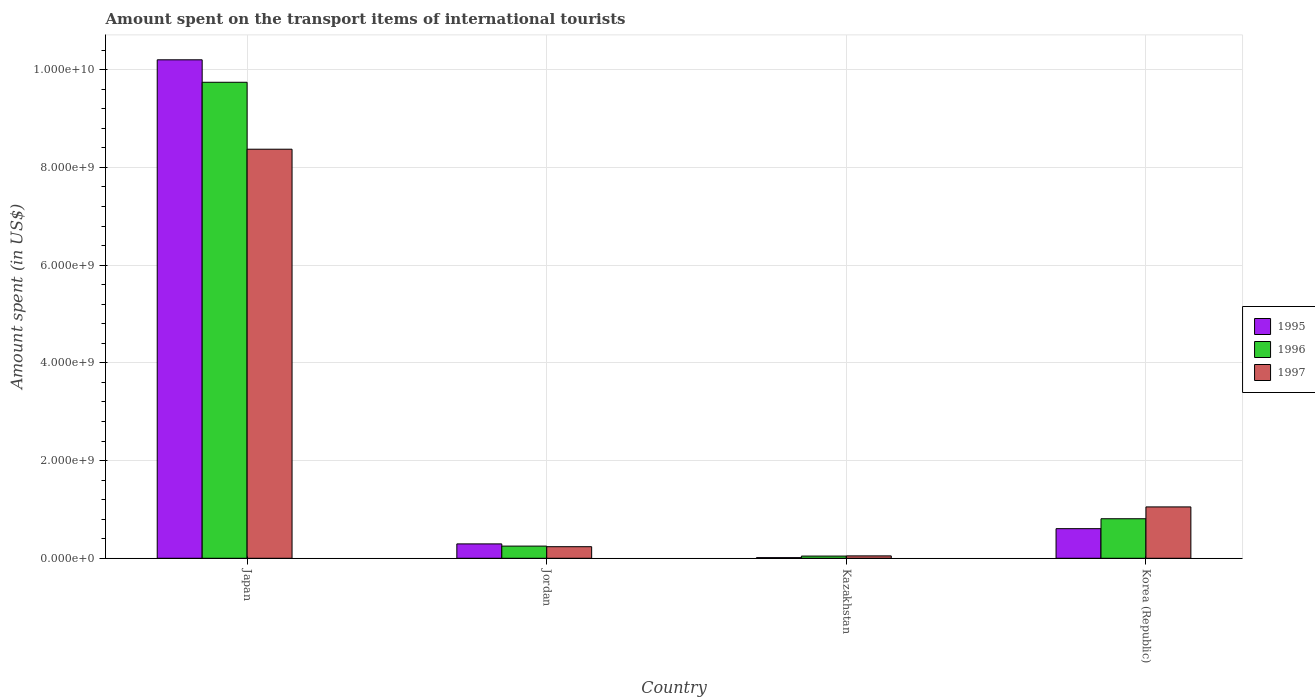How many different coloured bars are there?
Give a very brief answer. 3. Are the number of bars per tick equal to the number of legend labels?
Ensure brevity in your answer.  Yes. Are the number of bars on each tick of the X-axis equal?
Provide a succinct answer. Yes. How many bars are there on the 1st tick from the left?
Your response must be concise. 3. What is the label of the 3rd group of bars from the left?
Offer a very short reply. Kazakhstan. In how many cases, is the number of bars for a given country not equal to the number of legend labels?
Ensure brevity in your answer.  0. What is the amount spent on the transport items of international tourists in 1997 in Japan?
Provide a short and direct response. 8.37e+09. Across all countries, what is the maximum amount spent on the transport items of international tourists in 1996?
Provide a succinct answer. 9.74e+09. Across all countries, what is the minimum amount spent on the transport items of international tourists in 1996?
Keep it short and to the point. 4.50e+07. In which country was the amount spent on the transport items of international tourists in 1997 maximum?
Offer a terse response. Japan. In which country was the amount spent on the transport items of international tourists in 1997 minimum?
Offer a very short reply. Kazakhstan. What is the total amount spent on the transport items of international tourists in 1996 in the graph?
Provide a short and direct response. 1.08e+1. What is the difference between the amount spent on the transport items of international tourists in 1995 in Jordan and that in Kazakhstan?
Keep it short and to the point. 2.81e+08. What is the difference between the amount spent on the transport items of international tourists in 1997 in Jordan and the amount spent on the transport items of international tourists in 1995 in Kazakhstan?
Make the answer very short. 2.24e+08. What is the average amount spent on the transport items of international tourists in 1995 per country?
Keep it short and to the point. 2.78e+09. What is the difference between the amount spent on the transport items of international tourists of/in 1997 and amount spent on the transport items of international tourists of/in 1996 in Jordan?
Give a very brief answer. -1.20e+07. What is the ratio of the amount spent on the transport items of international tourists in 1996 in Japan to that in Jordan?
Ensure brevity in your answer.  39.12. Is the difference between the amount spent on the transport items of international tourists in 1997 in Jordan and Kazakhstan greater than the difference between the amount spent on the transport items of international tourists in 1996 in Jordan and Kazakhstan?
Your answer should be compact. No. What is the difference between the highest and the second highest amount spent on the transport items of international tourists in 1995?
Ensure brevity in your answer.  9.60e+09. What is the difference between the highest and the lowest amount spent on the transport items of international tourists in 1995?
Keep it short and to the point. 1.02e+1. Is the sum of the amount spent on the transport items of international tourists in 1996 in Jordan and Kazakhstan greater than the maximum amount spent on the transport items of international tourists in 1995 across all countries?
Keep it short and to the point. No. What does the 3rd bar from the right in Japan represents?
Your answer should be compact. 1995. What is the difference between two consecutive major ticks on the Y-axis?
Provide a short and direct response. 2.00e+09. Are the values on the major ticks of Y-axis written in scientific E-notation?
Your answer should be compact. Yes. Does the graph contain any zero values?
Provide a short and direct response. No. How many legend labels are there?
Offer a very short reply. 3. What is the title of the graph?
Offer a terse response. Amount spent on the transport items of international tourists. Does "2011" appear as one of the legend labels in the graph?
Your answer should be compact. No. What is the label or title of the Y-axis?
Your response must be concise. Amount spent (in US$). What is the Amount spent (in US$) in 1995 in Japan?
Make the answer very short. 1.02e+1. What is the Amount spent (in US$) in 1996 in Japan?
Your response must be concise. 9.74e+09. What is the Amount spent (in US$) of 1997 in Japan?
Provide a short and direct response. 8.37e+09. What is the Amount spent (in US$) of 1995 in Jordan?
Provide a succinct answer. 2.94e+08. What is the Amount spent (in US$) of 1996 in Jordan?
Your answer should be compact. 2.49e+08. What is the Amount spent (in US$) of 1997 in Jordan?
Provide a short and direct response. 2.37e+08. What is the Amount spent (in US$) in 1995 in Kazakhstan?
Your answer should be compact. 1.30e+07. What is the Amount spent (in US$) in 1996 in Kazakhstan?
Your response must be concise. 4.50e+07. What is the Amount spent (in US$) of 1997 in Kazakhstan?
Make the answer very short. 4.90e+07. What is the Amount spent (in US$) of 1995 in Korea (Republic)?
Your answer should be compact. 6.06e+08. What is the Amount spent (in US$) in 1996 in Korea (Republic)?
Your answer should be very brief. 8.09e+08. What is the Amount spent (in US$) of 1997 in Korea (Republic)?
Provide a short and direct response. 1.05e+09. Across all countries, what is the maximum Amount spent (in US$) in 1995?
Your answer should be very brief. 1.02e+1. Across all countries, what is the maximum Amount spent (in US$) in 1996?
Offer a terse response. 9.74e+09. Across all countries, what is the maximum Amount spent (in US$) in 1997?
Give a very brief answer. 8.37e+09. Across all countries, what is the minimum Amount spent (in US$) of 1995?
Keep it short and to the point. 1.30e+07. Across all countries, what is the minimum Amount spent (in US$) in 1996?
Ensure brevity in your answer.  4.50e+07. Across all countries, what is the minimum Amount spent (in US$) of 1997?
Your response must be concise. 4.90e+07. What is the total Amount spent (in US$) in 1995 in the graph?
Make the answer very short. 1.11e+1. What is the total Amount spent (in US$) in 1996 in the graph?
Offer a very short reply. 1.08e+1. What is the total Amount spent (in US$) of 1997 in the graph?
Your answer should be very brief. 9.71e+09. What is the difference between the Amount spent (in US$) of 1995 in Japan and that in Jordan?
Provide a succinct answer. 9.91e+09. What is the difference between the Amount spent (in US$) of 1996 in Japan and that in Jordan?
Keep it short and to the point. 9.49e+09. What is the difference between the Amount spent (in US$) of 1997 in Japan and that in Jordan?
Keep it short and to the point. 8.14e+09. What is the difference between the Amount spent (in US$) in 1995 in Japan and that in Kazakhstan?
Your answer should be very brief. 1.02e+1. What is the difference between the Amount spent (in US$) in 1996 in Japan and that in Kazakhstan?
Provide a succinct answer. 9.70e+09. What is the difference between the Amount spent (in US$) in 1997 in Japan and that in Kazakhstan?
Provide a short and direct response. 8.32e+09. What is the difference between the Amount spent (in US$) of 1995 in Japan and that in Korea (Republic)?
Keep it short and to the point. 9.60e+09. What is the difference between the Amount spent (in US$) in 1996 in Japan and that in Korea (Republic)?
Offer a terse response. 8.93e+09. What is the difference between the Amount spent (in US$) in 1997 in Japan and that in Korea (Republic)?
Your answer should be very brief. 7.32e+09. What is the difference between the Amount spent (in US$) of 1995 in Jordan and that in Kazakhstan?
Keep it short and to the point. 2.81e+08. What is the difference between the Amount spent (in US$) of 1996 in Jordan and that in Kazakhstan?
Make the answer very short. 2.04e+08. What is the difference between the Amount spent (in US$) of 1997 in Jordan and that in Kazakhstan?
Your answer should be very brief. 1.88e+08. What is the difference between the Amount spent (in US$) in 1995 in Jordan and that in Korea (Republic)?
Offer a very short reply. -3.12e+08. What is the difference between the Amount spent (in US$) in 1996 in Jordan and that in Korea (Republic)?
Offer a terse response. -5.60e+08. What is the difference between the Amount spent (in US$) of 1997 in Jordan and that in Korea (Republic)?
Your answer should be very brief. -8.14e+08. What is the difference between the Amount spent (in US$) in 1995 in Kazakhstan and that in Korea (Republic)?
Provide a short and direct response. -5.93e+08. What is the difference between the Amount spent (in US$) of 1996 in Kazakhstan and that in Korea (Republic)?
Your response must be concise. -7.64e+08. What is the difference between the Amount spent (in US$) of 1997 in Kazakhstan and that in Korea (Republic)?
Make the answer very short. -1.00e+09. What is the difference between the Amount spent (in US$) in 1995 in Japan and the Amount spent (in US$) in 1996 in Jordan?
Your answer should be very brief. 9.95e+09. What is the difference between the Amount spent (in US$) in 1995 in Japan and the Amount spent (in US$) in 1997 in Jordan?
Provide a short and direct response. 9.96e+09. What is the difference between the Amount spent (in US$) of 1996 in Japan and the Amount spent (in US$) of 1997 in Jordan?
Offer a very short reply. 9.50e+09. What is the difference between the Amount spent (in US$) in 1995 in Japan and the Amount spent (in US$) in 1996 in Kazakhstan?
Make the answer very short. 1.02e+1. What is the difference between the Amount spent (in US$) of 1995 in Japan and the Amount spent (in US$) of 1997 in Kazakhstan?
Provide a succinct answer. 1.02e+1. What is the difference between the Amount spent (in US$) of 1996 in Japan and the Amount spent (in US$) of 1997 in Kazakhstan?
Provide a succinct answer. 9.69e+09. What is the difference between the Amount spent (in US$) in 1995 in Japan and the Amount spent (in US$) in 1996 in Korea (Republic)?
Your response must be concise. 9.39e+09. What is the difference between the Amount spent (in US$) in 1995 in Japan and the Amount spent (in US$) in 1997 in Korea (Republic)?
Make the answer very short. 9.15e+09. What is the difference between the Amount spent (in US$) of 1996 in Japan and the Amount spent (in US$) of 1997 in Korea (Republic)?
Provide a short and direct response. 8.69e+09. What is the difference between the Amount spent (in US$) of 1995 in Jordan and the Amount spent (in US$) of 1996 in Kazakhstan?
Provide a short and direct response. 2.49e+08. What is the difference between the Amount spent (in US$) in 1995 in Jordan and the Amount spent (in US$) in 1997 in Kazakhstan?
Your response must be concise. 2.45e+08. What is the difference between the Amount spent (in US$) of 1996 in Jordan and the Amount spent (in US$) of 1997 in Kazakhstan?
Provide a succinct answer. 2.00e+08. What is the difference between the Amount spent (in US$) in 1995 in Jordan and the Amount spent (in US$) in 1996 in Korea (Republic)?
Provide a succinct answer. -5.15e+08. What is the difference between the Amount spent (in US$) of 1995 in Jordan and the Amount spent (in US$) of 1997 in Korea (Republic)?
Provide a short and direct response. -7.57e+08. What is the difference between the Amount spent (in US$) in 1996 in Jordan and the Amount spent (in US$) in 1997 in Korea (Republic)?
Your answer should be very brief. -8.02e+08. What is the difference between the Amount spent (in US$) in 1995 in Kazakhstan and the Amount spent (in US$) in 1996 in Korea (Republic)?
Provide a short and direct response. -7.96e+08. What is the difference between the Amount spent (in US$) of 1995 in Kazakhstan and the Amount spent (in US$) of 1997 in Korea (Republic)?
Give a very brief answer. -1.04e+09. What is the difference between the Amount spent (in US$) in 1996 in Kazakhstan and the Amount spent (in US$) in 1997 in Korea (Republic)?
Ensure brevity in your answer.  -1.01e+09. What is the average Amount spent (in US$) in 1995 per country?
Offer a terse response. 2.78e+09. What is the average Amount spent (in US$) of 1996 per country?
Offer a terse response. 2.71e+09. What is the average Amount spent (in US$) in 1997 per country?
Your response must be concise. 2.43e+09. What is the difference between the Amount spent (in US$) of 1995 and Amount spent (in US$) of 1996 in Japan?
Make the answer very short. 4.60e+08. What is the difference between the Amount spent (in US$) in 1995 and Amount spent (in US$) in 1997 in Japan?
Provide a short and direct response. 1.83e+09. What is the difference between the Amount spent (in US$) in 1996 and Amount spent (in US$) in 1997 in Japan?
Provide a succinct answer. 1.37e+09. What is the difference between the Amount spent (in US$) in 1995 and Amount spent (in US$) in 1996 in Jordan?
Offer a very short reply. 4.50e+07. What is the difference between the Amount spent (in US$) in 1995 and Amount spent (in US$) in 1997 in Jordan?
Your answer should be compact. 5.70e+07. What is the difference between the Amount spent (in US$) in 1995 and Amount spent (in US$) in 1996 in Kazakhstan?
Give a very brief answer. -3.20e+07. What is the difference between the Amount spent (in US$) of 1995 and Amount spent (in US$) of 1997 in Kazakhstan?
Provide a short and direct response. -3.60e+07. What is the difference between the Amount spent (in US$) in 1995 and Amount spent (in US$) in 1996 in Korea (Republic)?
Your answer should be very brief. -2.03e+08. What is the difference between the Amount spent (in US$) of 1995 and Amount spent (in US$) of 1997 in Korea (Republic)?
Offer a terse response. -4.45e+08. What is the difference between the Amount spent (in US$) in 1996 and Amount spent (in US$) in 1997 in Korea (Republic)?
Offer a terse response. -2.42e+08. What is the ratio of the Amount spent (in US$) of 1995 in Japan to that in Jordan?
Make the answer very short. 34.7. What is the ratio of the Amount spent (in US$) in 1996 in Japan to that in Jordan?
Keep it short and to the point. 39.12. What is the ratio of the Amount spent (in US$) in 1997 in Japan to that in Jordan?
Offer a terse response. 35.32. What is the ratio of the Amount spent (in US$) in 1995 in Japan to that in Kazakhstan?
Offer a terse response. 784.77. What is the ratio of the Amount spent (in US$) in 1996 in Japan to that in Kazakhstan?
Provide a succinct answer. 216.49. What is the ratio of the Amount spent (in US$) in 1997 in Japan to that in Kazakhstan?
Provide a short and direct response. 170.86. What is the ratio of the Amount spent (in US$) in 1995 in Japan to that in Korea (Republic)?
Give a very brief answer. 16.84. What is the ratio of the Amount spent (in US$) in 1996 in Japan to that in Korea (Republic)?
Your response must be concise. 12.04. What is the ratio of the Amount spent (in US$) in 1997 in Japan to that in Korea (Republic)?
Your answer should be very brief. 7.97. What is the ratio of the Amount spent (in US$) in 1995 in Jordan to that in Kazakhstan?
Give a very brief answer. 22.62. What is the ratio of the Amount spent (in US$) in 1996 in Jordan to that in Kazakhstan?
Offer a very short reply. 5.53. What is the ratio of the Amount spent (in US$) of 1997 in Jordan to that in Kazakhstan?
Provide a short and direct response. 4.84. What is the ratio of the Amount spent (in US$) of 1995 in Jordan to that in Korea (Republic)?
Offer a terse response. 0.49. What is the ratio of the Amount spent (in US$) in 1996 in Jordan to that in Korea (Republic)?
Keep it short and to the point. 0.31. What is the ratio of the Amount spent (in US$) of 1997 in Jordan to that in Korea (Republic)?
Your answer should be very brief. 0.23. What is the ratio of the Amount spent (in US$) of 1995 in Kazakhstan to that in Korea (Republic)?
Give a very brief answer. 0.02. What is the ratio of the Amount spent (in US$) of 1996 in Kazakhstan to that in Korea (Republic)?
Provide a short and direct response. 0.06. What is the ratio of the Amount spent (in US$) in 1997 in Kazakhstan to that in Korea (Republic)?
Your response must be concise. 0.05. What is the difference between the highest and the second highest Amount spent (in US$) of 1995?
Your response must be concise. 9.60e+09. What is the difference between the highest and the second highest Amount spent (in US$) of 1996?
Keep it short and to the point. 8.93e+09. What is the difference between the highest and the second highest Amount spent (in US$) in 1997?
Ensure brevity in your answer.  7.32e+09. What is the difference between the highest and the lowest Amount spent (in US$) of 1995?
Your answer should be compact. 1.02e+1. What is the difference between the highest and the lowest Amount spent (in US$) in 1996?
Provide a succinct answer. 9.70e+09. What is the difference between the highest and the lowest Amount spent (in US$) of 1997?
Your response must be concise. 8.32e+09. 